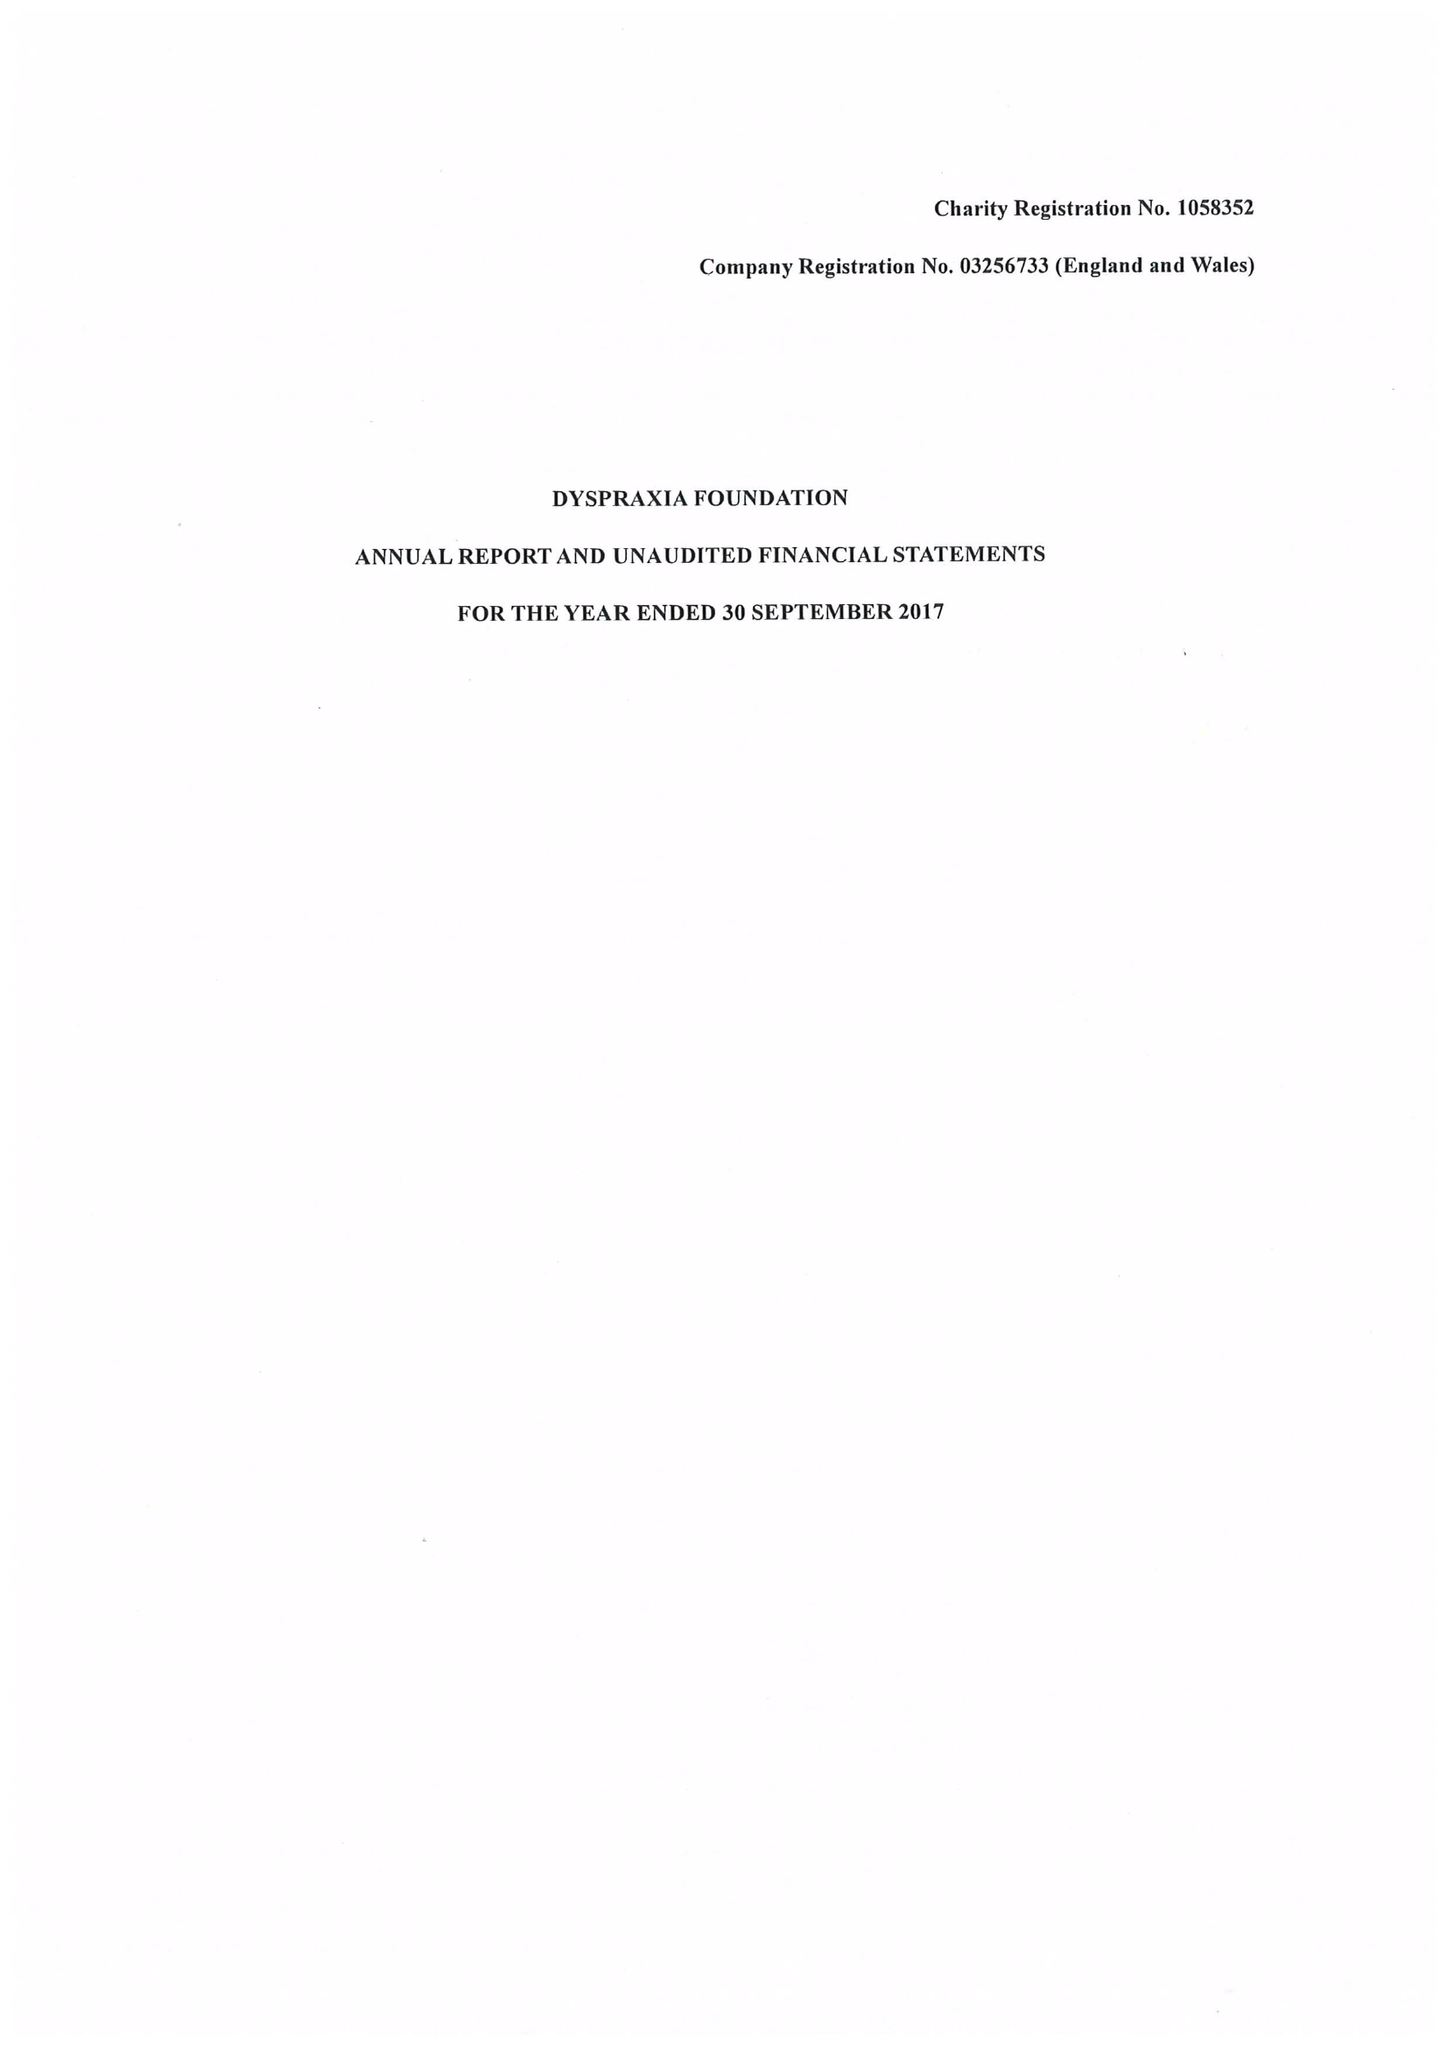What is the value for the address__street_line?
Answer the question using a single word or phrase. 8 WEST ALLEY 